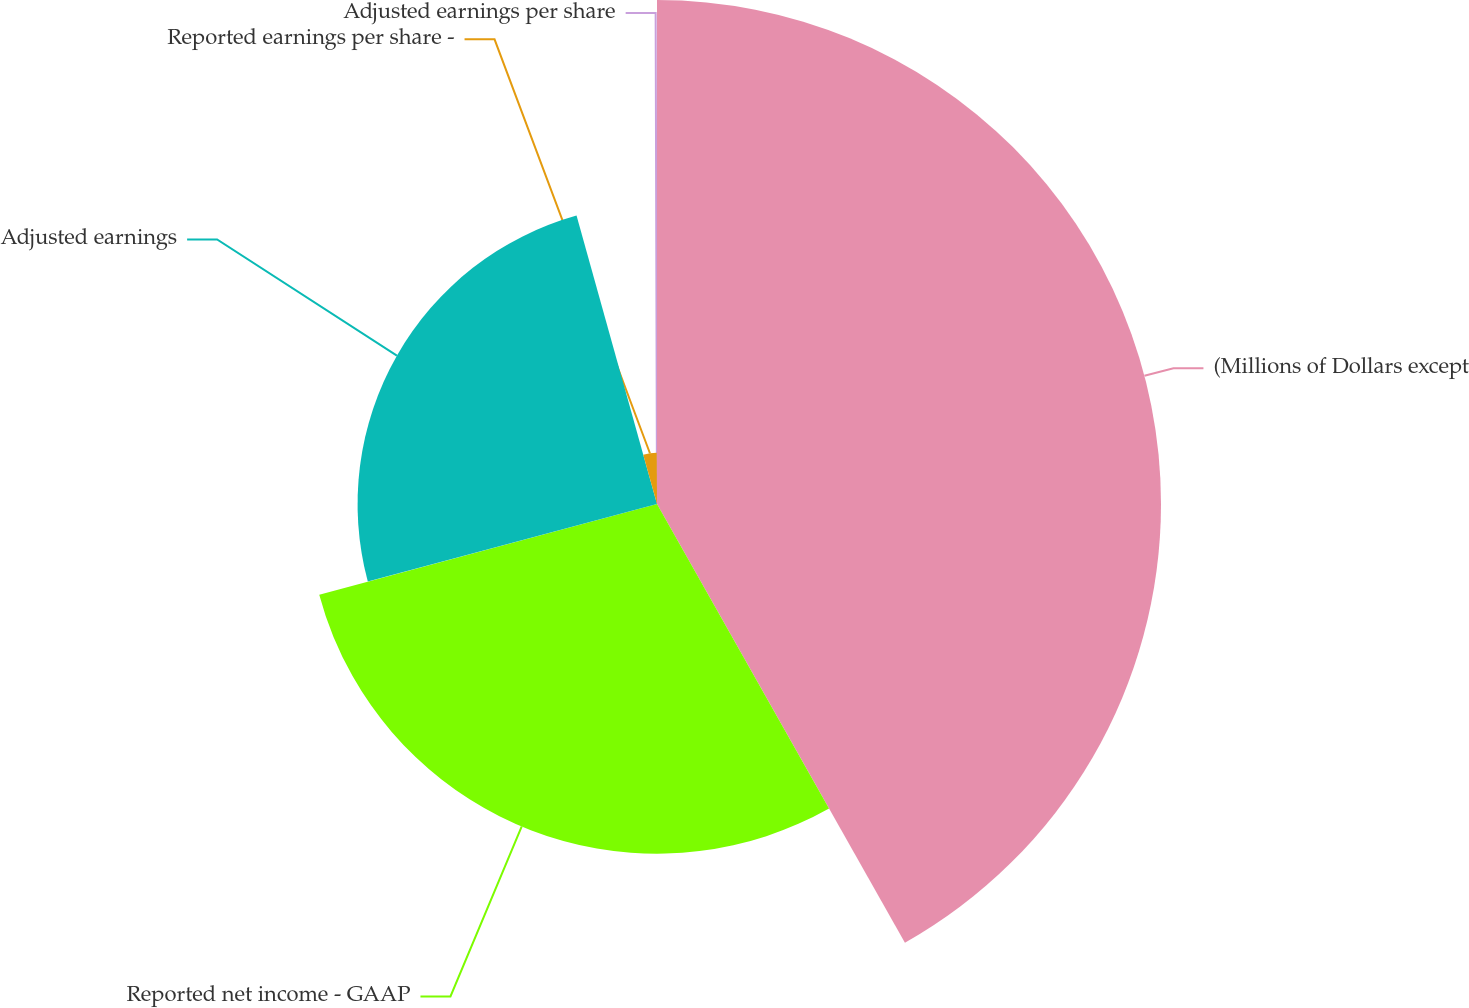<chart> <loc_0><loc_0><loc_500><loc_500><pie_chart><fcel>(Millions of Dollars except<fcel>Reported net income - GAAP<fcel>Adjusted earnings<fcel>Reported earnings per share -<fcel>Adjusted earnings per share<nl><fcel>41.81%<fcel>29.01%<fcel>24.84%<fcel>4.25%<fcel>0.08%<nl></chart> 